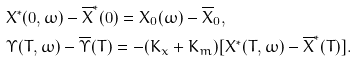Convert formula to latex. <formula><loc_0><loc_0><loc_500><loc_500>& X ^ { * } ( 0 , \omega ) - \overline { X } ^ { * } ( 0 ) = X _ { 0 } ( \omega ) - \overline { X } _ { 0 } , \\ & \Upsilon ( T , \omega ) - \overline { \Upsilon } ( T ) = - ( K _ { x } + K _ { m } ) [ X ^ { * } ( T , \omega ) - \overline { X } ^ { * } ( T ) ] .</formula> 